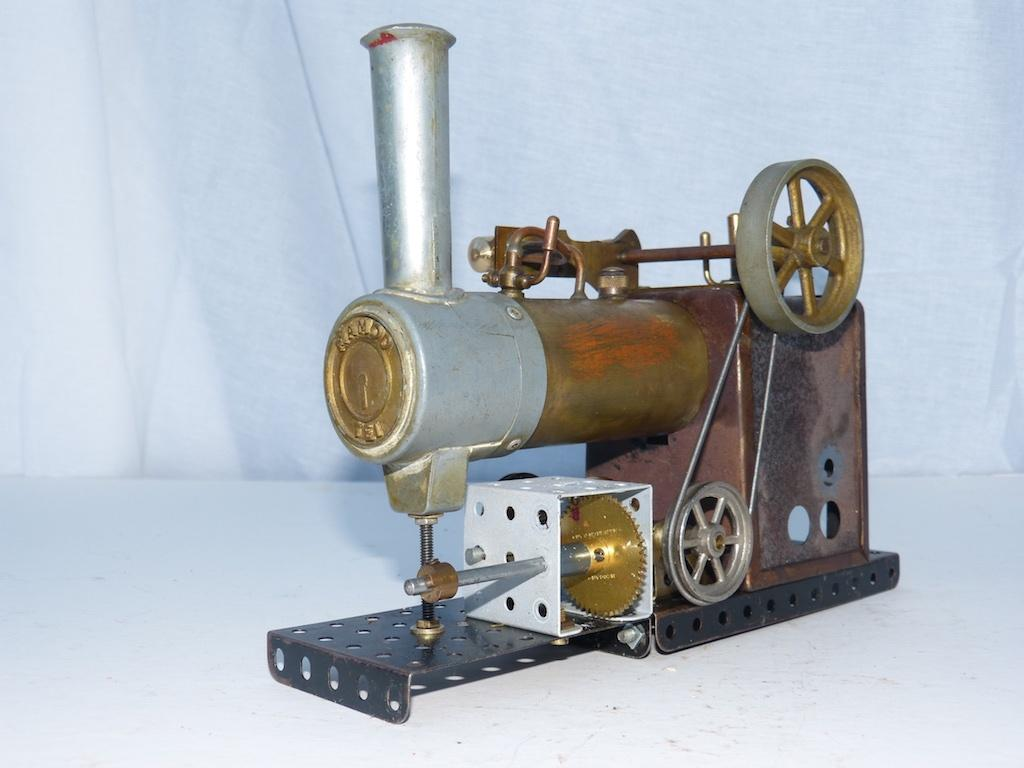What is the main subject in the image? There is a machine in the image. How many flowers are surrounding the queen and boys in the image? There are no flowers, queen, or boys present in the image; it only features a machine. 